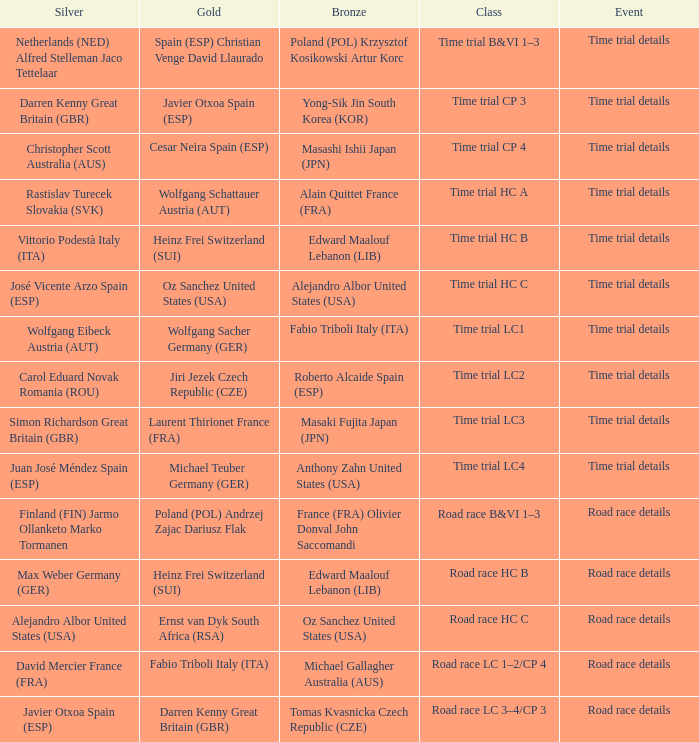Who received gold when silver is wolfgang eibeck austria (aut)? Wolfgang Sacher Germany (GER). 